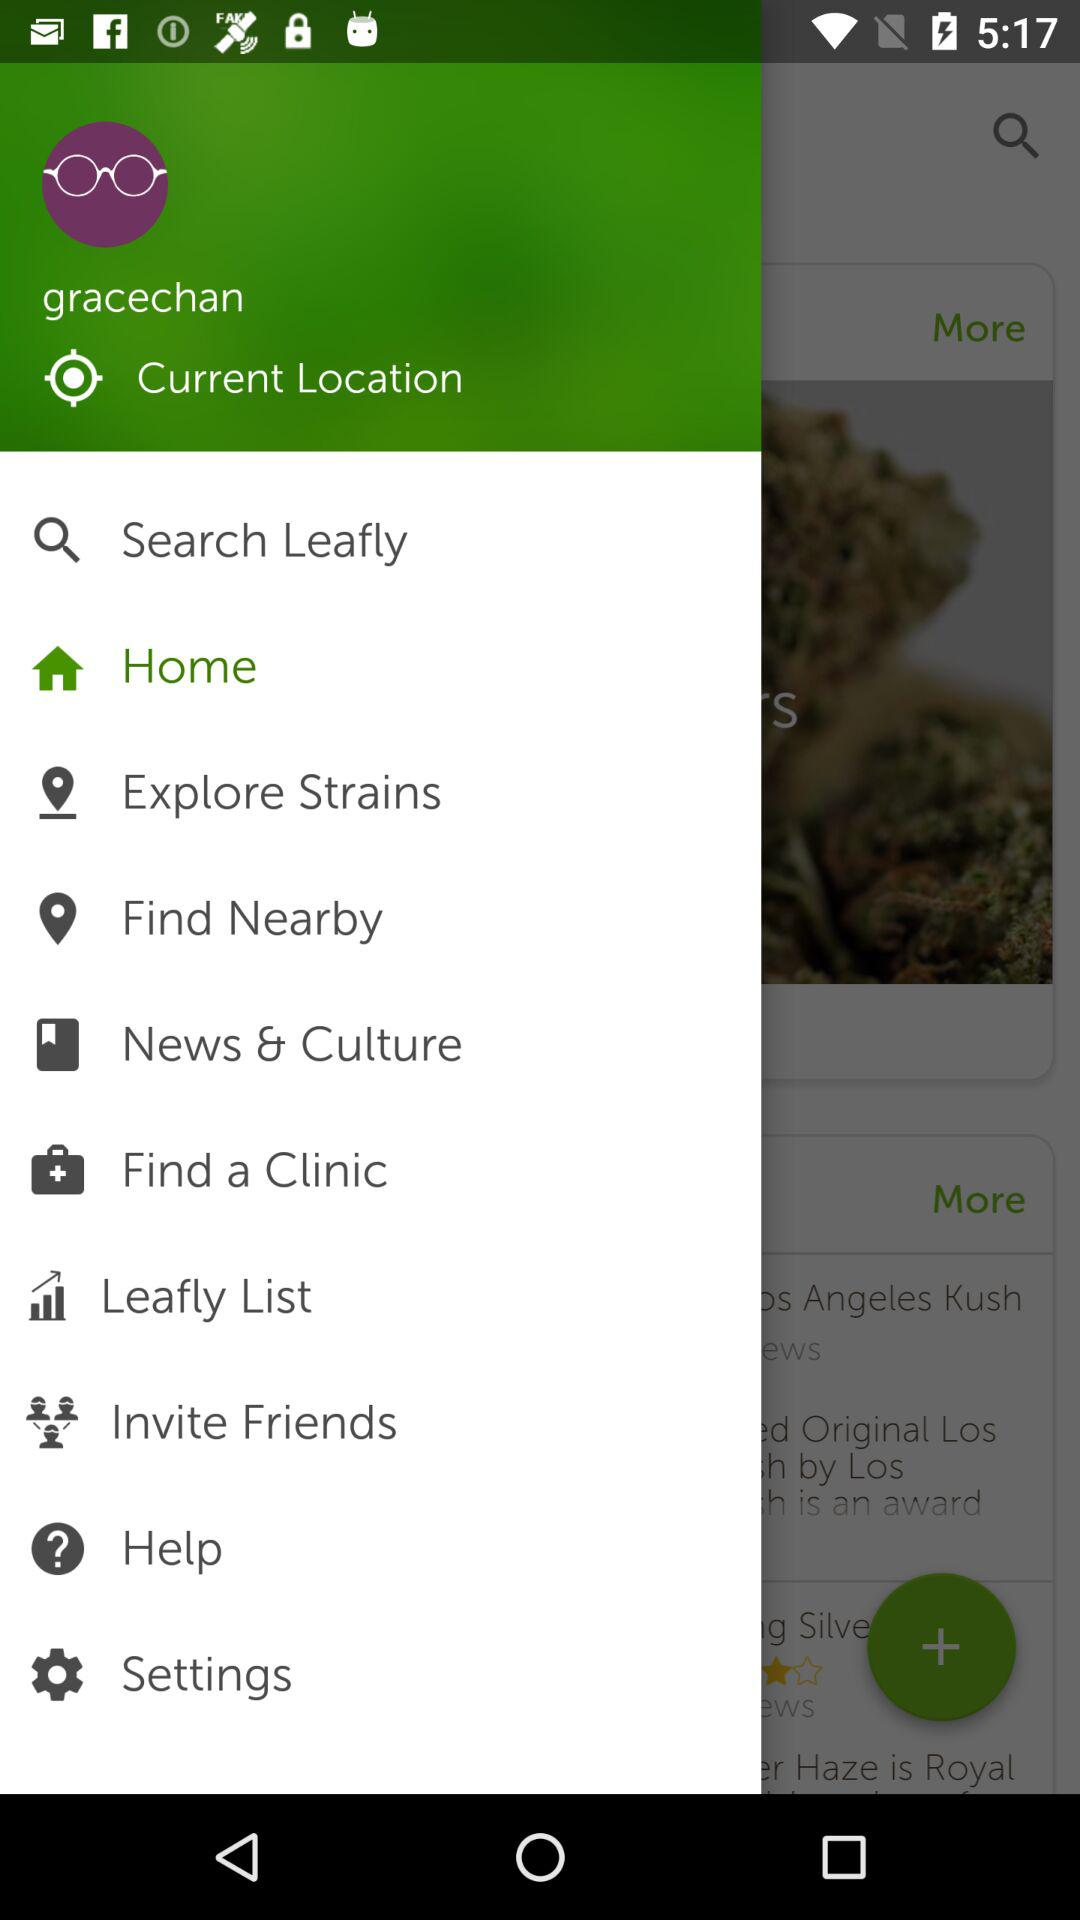What is the user name? The user name is Grace Chan. 